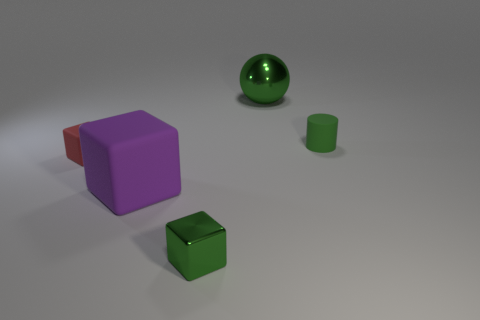Subtract all tiny blocks. How many blocks are left? 1 Subtract all green cubes. How many cubes are left? 2 Add 3 metal blocks. How many objects exist? 8 Subtract 0 red balls. How many objects are left? 5 Subtract all spheres. How many objects are left? 4 Subtract 1 blocks. How many blocks are left? 2 Subtract all brown cylinders. Subtract all gray balls. How many cylinders are left? 1 Subtract all large rubber blocks. Subtract all small red things. How many objects are left? 3 Add 5 red objects. How many red objects are left? 6 Add 4 large yellow metal objects. How many large yellow metal objects exist? 4 